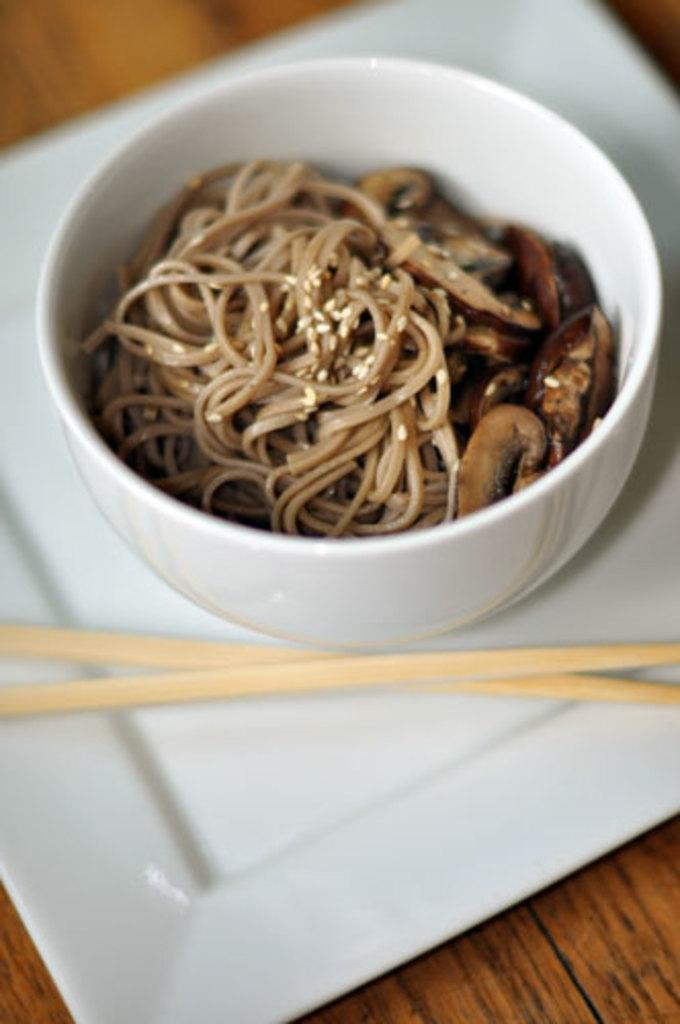What is placed on the table in the image? There is a white color plate on the table. What utensils are on the plate? There are two chopsticks on the plate. What is the bowl used for in the image? There is a bowl on the plate, which contains a food item. What type of fruit is on the board in the image? There is no board or fruit present in the image. 